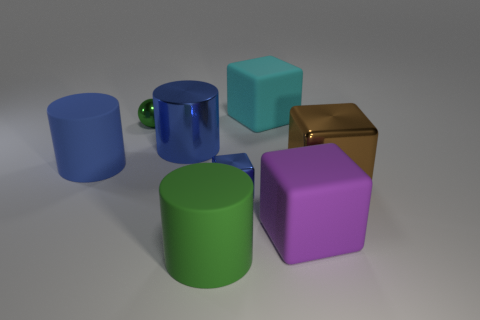There is a big cylinder that is the same color as the shiny sphere; what material is it?
Your answer should be very brief. Rubber. What number of tiny green cubes are there?
Keep it short and to the point. 0. Do the tiny green metal object and the big matte thing that is right of the cyan rubber cube have the same shape?
Your answer should be compact. No. How many things are big purple matte cubes or things that are in front of the shiny ball?
Provide a succinct answer. 6. There is a brown object that is the same shape as the big cyan object; what material is it?
Make the answer very short. Metal. Does the small metallic object that is in front of the shiny ball have the same shape as the big purple matte object?
Your answer should be compact. Yes. Are there any other things that have the same size as the green sphere?
Ensure brevity in your answer.  Yes. Is the number of large matte cylinders that are on the right side of the shiny cylinder less than the number of metal balls that are in front of the large brown metal thing?
Provide a short and direct response. No. What number of other objects are there of the same shape as the tiny green metal object?
Provide a succinct answer. 0. There is a cylinder in front of the small metal thing right of the green object in front of the big shiny cylinder; what size is it?
Ensure brevity in your answer.  Large. 